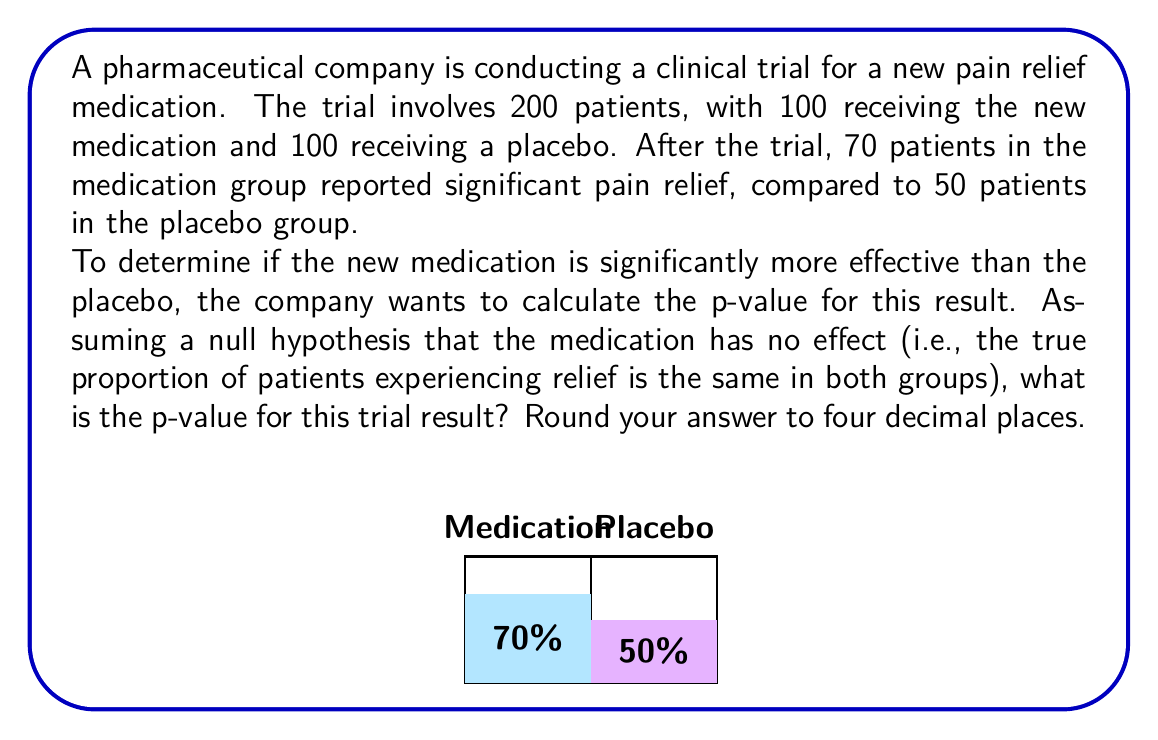Provide a solution to this math problem. To calculate the p-value, we'll use the normal approximation to the binomial distribution. Here's the step-by-step process:

1) Under the null hypothesis, we assume the true proportion of patients experiencing relief is the same in both groups. We can estimate this common proportion:

   $$\hat{p} = \frac{70 + 50}{200} = 0.6$$

2) The test statistic is the difference in proportions:

   $$\hat{p}_1 - \hat{p}_2 = \frac{70}{100} - \frac{50}{100} = 0.7 - 0.5 = 0.2$$

3) The standard error of this difference under the null hypothesis is:

   $$SE = \sqrt{\hat{p}(1-\hat{p})(\frac{1}{n_1} + \frac{1}{n_2})}$$
   $$SE = \sqrt{0.6(1-0.6)(\frac{1}{100} + \frac{1}{100})} = \sqrt{0.24 \cdot 0.02} = 0.0693$$

4) The z-score is:

   $$z = \frac{\hat{p}_1 - \hat{p}_2}{SE} = \frac{0.2}{0.0693} = 2.887$$

5) The p-value is the probability of observing a result this extreme or more extreme under the null hypothesis. For a two-tailed test, this is:

   $$p = 2 \cdot P(Z > 2.887)$$

6) Using a standard normal distribution table or calculator:

   $$P(Z > 2.887) = 0.00195$$

7) Therefore, the p-value is:

   $$p = 2 \cdot 0.00195 = 0.0039$$

Rounded to four decimal places, this gives 0.0039.
Answer: 0.0039 